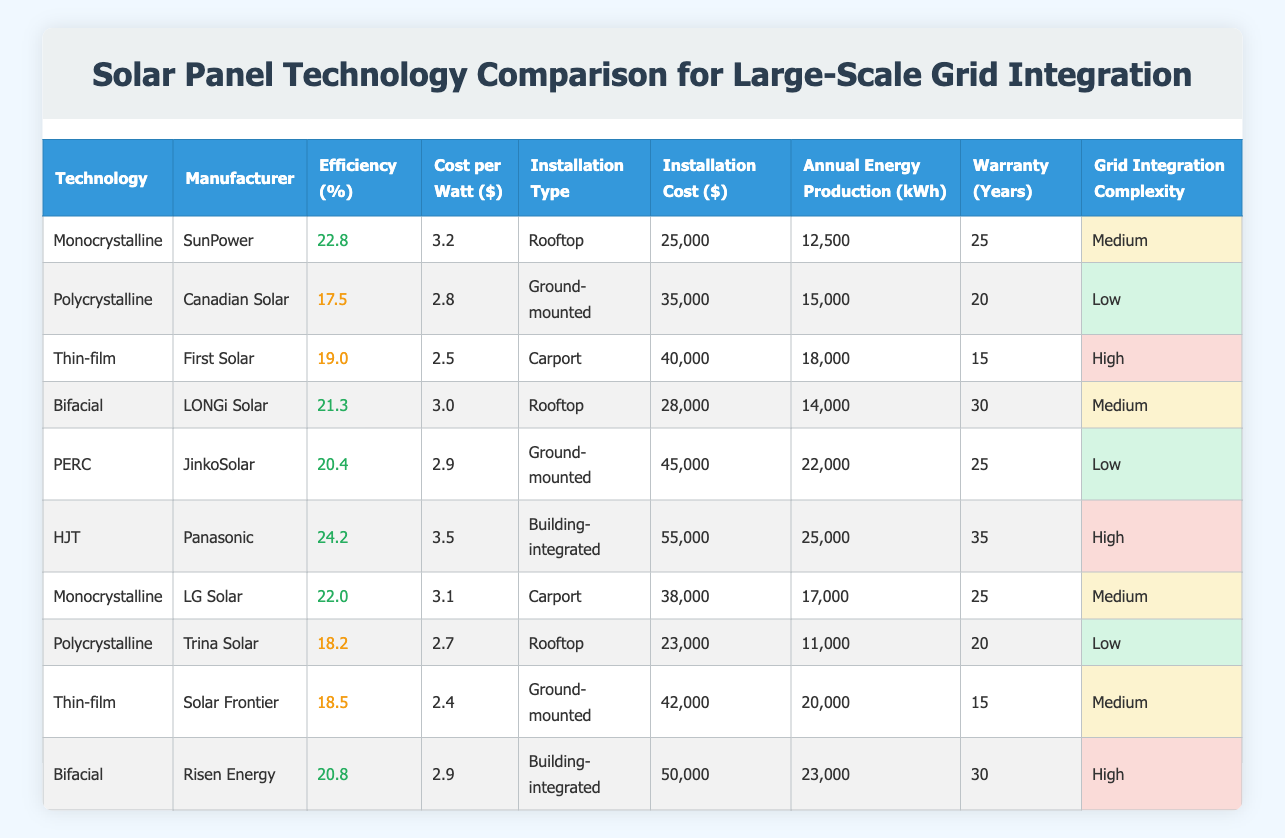What is the cost per watt for the most efficient solar panel technology? The most efficient solar panel technology in the table is HJT (Panasonic) with an efficiency of 24.2%. Looking at the cost per watt for HJT, it is listed as 3.5.
Answer: 3.5 Which installation type has the highest average installation cost? To find the average installation cost by type, we sum the installation costs for each type and divide by the number. The sums are: Rooftop (25000 + 28000 + 23000 = 76000) → 76000/3 = 25333. Ground-mounted (35000 + 45000 + 42000 = 122000) → 122000/3 = 40667. Carport (40000 + 38000 = 78000) → 78000/2 = 39000. Building-integrated (55000 + 50000 = 105000) → 105000/2 = 52500. The highest is Building-integrated at 52500.
Answer: Building-integrated Is the annual energy production of Polycrystalline technologies higher than that of Thin-film technologies? For Polycrystalline, we have Canadian Solar producing 15000 kWh and Trina Solar producing 11000 kWh, summing this gives 15000 + 11000 = 26000 kWh. For Thin-film, First Solar produces 18000 kWh, and Solar Frontier produces 20000 kWh, summing gives 18000 + 20000 = 38000 kWh. Since 38000 > 26000, the answer is yes.
Answer: Yes What is the average efficiency of all the Bifacial technologies listed? The Bifacial manufacturers are LONGi Solar (21.3%) and Risen Energy (20.8%). To find the average: (21.3 + 20.8) / 2 = 21.05.
Answer: 21.05 Which technology has the lowest warranty period, and what is that period? Looking at the warranty column, both Thin-film technologies (First Solar and Solar Frontier) have a warranty of 15 years, which is the lowest compared to others.
Answer: 15 years Is there any technology with high grid integration complexity that has an efficiency over 24%? The only technology above 24% efficiency is HJT by Panasonic (24.2%) and its grid integration complexity is high. Therefore, the answer is yes.
Answer: Yes What is the difference in installation cost between the highest and lowest cost technologies? The highest installation cost is for HJT by Panasonic at 55000, and the lowest is for Thin-film by First Solar at 40000. The difference is 55000 - 40000 = 15000.
Answer: 15000 How many years of warranty do Bifacial technologies guarantee on average? The warranties for Bifacial technologies are 30 years for LONGi Solar and 30 years for Risen Energy. The average warranty is (30 + 30) / 2 = 30.
Answer: 30 years 